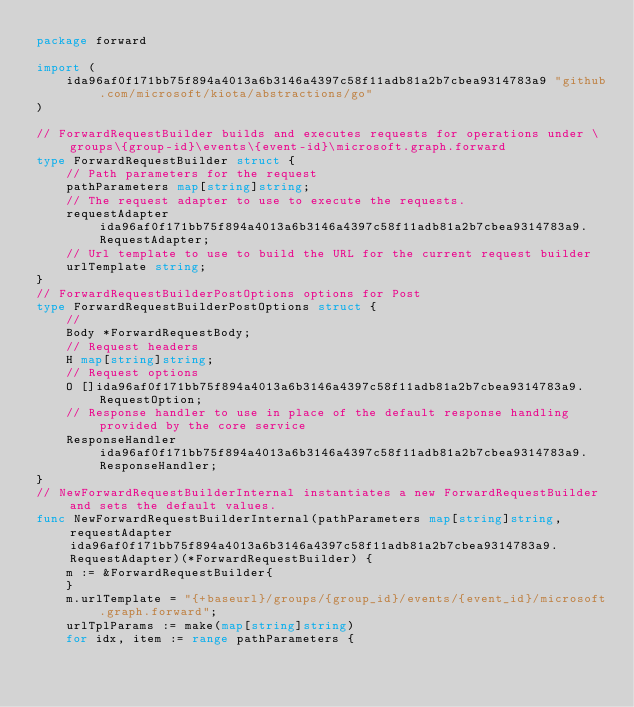<code> <loc_0><loc_0><loc_500><loc_500><_Go_>package forward

import (
    ida96af0f171bb75f894a4013a6b3146a4397c58f11adb81a2b7cbea9314783a9 "github.com/microsoft/kiota/abstractions/go"
)

// ForwardRequestBuilder builds and executes requests for operations under \groups\{group-id}\events\{event-id}\microsoft.graph.forward
type ForwardRequestBuilder struct {
    // Path parameters for the request
    pathParameters map[string]string;
    // The request adapter to use to execute the requests.
    requestAdapter ida96af0f171bb75f894a4013a6b3146a4397c58f11adb81a2b7cbea9314783a9.RequestAdapter;
    // Url template to use to build the URL for the current request builder
    urlTemplate string;
}
// ForwardRequestBuilderPostOptions options for Post
type ForwardRequestBuilderPostOptions struct {
    // 
    Body *ForwardRequestBody;
    // Request headers
    H map[string]string;
    // Request options
    O []ida96af0f171bb75f894a4013a6b3146a4397c58f11adb81a2b7cbea9314783a9.RequestOption;
    // Response handler to use in place of the default response handling provided by the core service
    ResponseHandler ida96af0f171bb75f894a4013a6b3146a4397c58f11adb81a2b7cbea9314783a9.ResponseHandler;
}
// NewForwardRequestBuilderInternal instantiates a new ForwardRequestBuilder and sets the default values.
func NewForwardRequestBuilderInternal(pathParameters map[string]string, requestAdapter ida96af0f171bb75f894a4013a6b3146a4397c58f11adb81a2b7cbea9314783a9.RequestAdapter)(*ForwardRequestBuilder) {
    m := &ForwardRequestBuilder{
    }
    m.urlTemplate = "{+baseurl}/groups/{group_id}/events/{event_id}/microsoft.graph.forward";
    urlTplParams := make(map[string]string)
    for idx, item := range pathParameters {</code> 